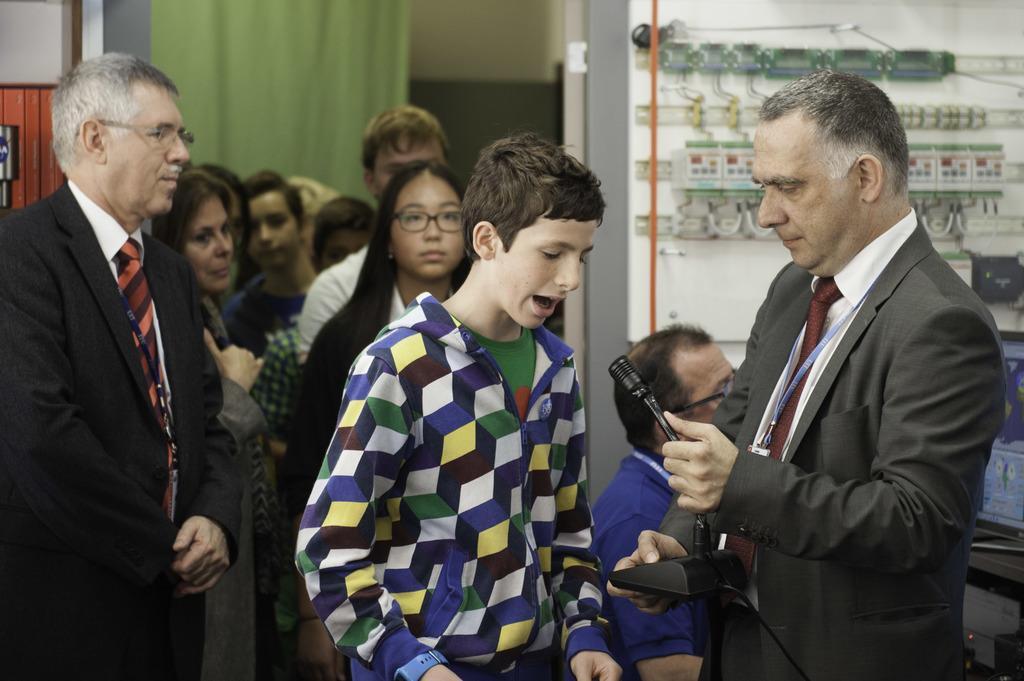Describe this image in one or two sentences. Here we can see few persons are standing and on the right a man is holding a micro phone in his hand. In the background we can see curtain,wall,electronic devices on the wall and a computer on the table. 